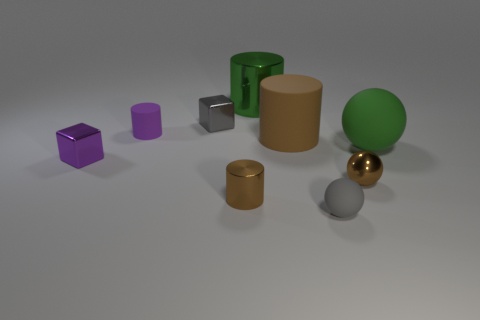Subtract all rubber balls. How many balls are left? 1 Subtract all gray spheres. How many brown cylinders are left? 2 Subtract all cubes. How many objects are left? 7 Subtract all cyan cylinders. Subtract all blue balls. How many cylinders are left? 4 Subtract 0 blue cubes. How many objects are left? 9 Subtract all small red shiny cubes. Subtract all purple metal objects. How many objects are left? 8 Add 3 shiny things. How many shiny things are left? 8 Add 1 rubber objects. How many rubber objects exist? 5 